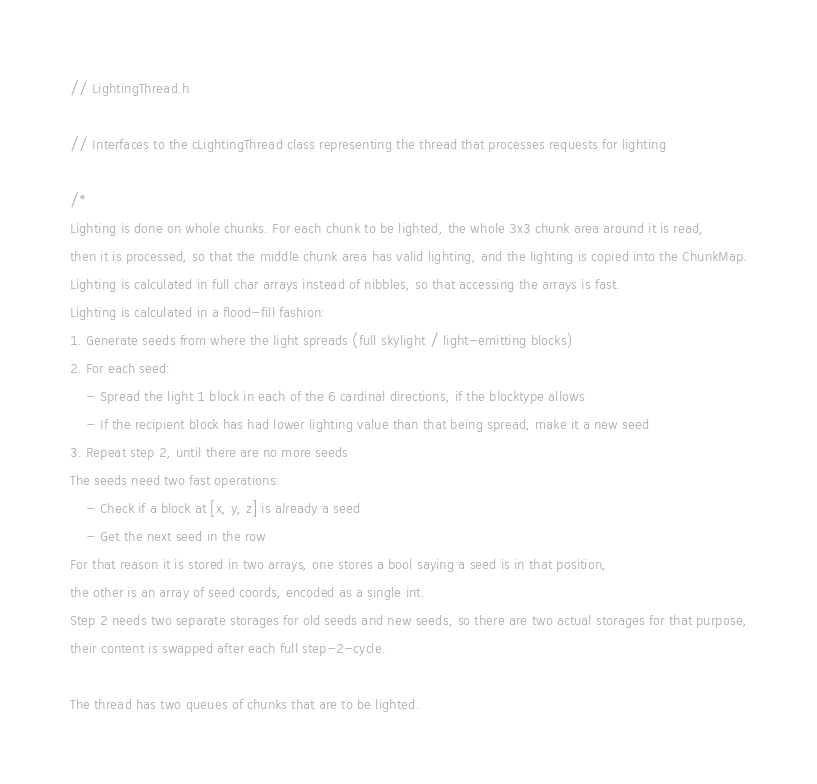Convert code to text. <code><loc_0><loc_0><loc_500><loc_500><_C_>
// LightingThread.h

// Interfaces to the cLightingThread class representing the thread that processes requests for lighting

/*
Lighting is done on whole chunks. For each chunk to be lighted, the whole 3x3 chunk area around it is read,
then it is processed, so that the middle chunk area has valid lighting, and the lighting is copied into the ChunkMap.
Lighting is calculated in full char arrays instead of nibbles, so that accessing the arrays is fast.
Lighting is calculated in a flood-fill fashion:
1. Generate seeds from where the light spreads (full skylight / light-emitting blocks)
2. For each seed:
	- Spread the light 1 block in each of the 6 cardinal directions, if the blocktype allows
	- If the recipient block has had lower lighting value than that being spread, make it a new seed
3. Repeat step 2, until there are no more seeds
The seeds need two fast operations:
	- Check if a block at [x, y, z] is already a seed
	- Get the next seed in the row
For that reason it is stored in two arrays, one stores a bool saying a seed is in that position,
the other is an array of seed coords, encoded as a single int.
Step 2 needs two separate storages for old seeds and new seeds, so there are two actual storages for that purpose,
their content is swapped after each full step-2-cycle.

The thread has two queues of chunks that are to be lighted.</code> 